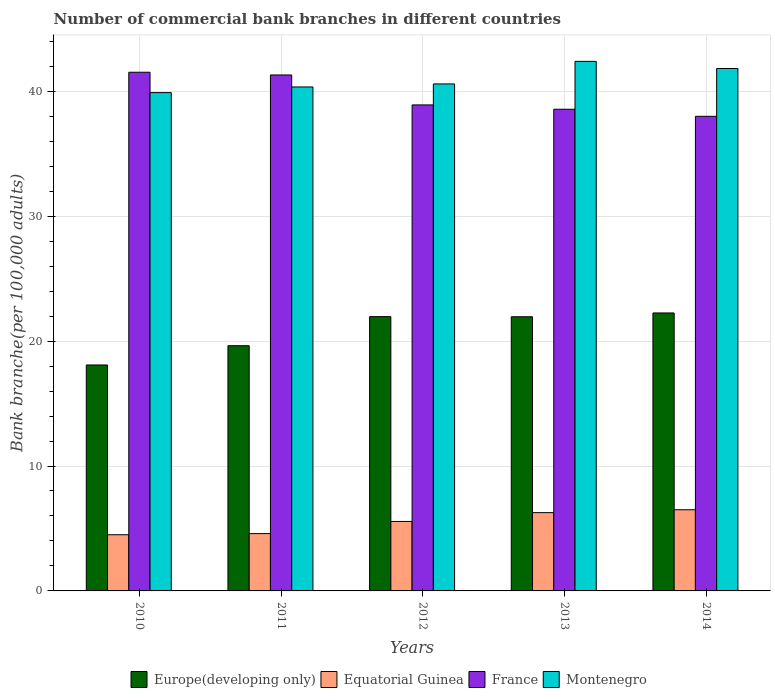Are the number of bars per tick equal to the number of legend labels?
Give a very brief answer. Yes. How many bars are there on the 4th tick from the right?
Provide a succinct answer. 4. What is the number of commercial bank branches in France in 2012?
Ensure brevity in your answer.  38.91. Across all years, what is the maximum number of commercial bank branches in Europe(developing only)?
Your response must be concise. 22.25. Across all years, what is the minimum number of commercial bank branches in Europe(developing only)?
Provide a succinct answer. 18.09. In which year was the number of commercial bank branches in France maximum?
Offer a very short reply. 2010. What is the total number of commercial bank branches in France in the graph?
Your answer should be compact. 198.3. What is the difference between the number of commercial bank branches in Equatorial Guinea in 2013 and that in 2014?
Make the answer very short. -0.23. What is the difference between the number of commercial bank branches in Europe(developing only) in 2011 and the number of commercial bank branches in France in 2014?
Ensure brevity in your answer.  -18.37. What is the average number of commercial bank branches in Europe(developing only) per year?
Give a very brief answer. 20.78. In the year 2012, what is the difference between the number of commercial bank branches in Europe(developing only) and number of commercial bank branches in Montenegro?
Give a very brief answer. -18.63. What is the ratio of the number of commercial bank branches in Europe(developing only) in 2011 to that in 2014?
Provide a succinct answer. 0.88. Is the difference between the number of commercial bank branches in Europe(developing only) in 2010 and 2013 greater than the difference between the number of commercial bank branches in Montenegro in 2010 and 2013?
Make the answer very short. No. What is the difference between the highest and the second highest number of commercial bank branches in France?
Keep it short and to the point. 0.22. What is the difference between the highest and the lowest number of commercial bank branches in Montenegro?
Keep it short and to the point. 2.5. In how many years, is the number of commercial bank branches in Europe(developing only) greater than the average number of commercial bank branches in Europe(developing only) taken over all years?
Offer a very short reply. 3. Is the sum of the number of commercial bank branches in Europe(developing only) in 2010 and 2012 greater than the maximum number of commercial bank branches in Montenegro across all years?
Keep it short and to the point. No. What does the 4th bar from the left in 2013 represents?
Provide a short and direct response. Montenegro. What does the 3rd bar from the right in 2014 represents?
Provide a succinct answer. Equatorial Guinea. Is it the case that in every year, the sum of the number of commercial bank branches in France and number of commercial bank branches in Equatorial Guinea is greater than the number of commercial bank branches in Montenegro?
Keep it short and to the point. Yes. How many bars are there?
Keep it short and to the point. 20. What is the difference between two consecutive major ticks on the Y-axis?
Your answer should be compact. 10. Are the values on the major ticks of Y-axis written in scientific E-notation?
Provide a short and direct response. No. Where does the legend appear in the graph?
Your answer should be very brief. Bottom center. How many legend labels are there?
Offer a terse response. 4. How are the legend labels stacked?
Ensure brevity in your answer.  Horizontal. What is the title of the graph?
Your response must be concise. Number of commercial bank branches in different countries. Does "Albania" appear as one of the legend labels in the graph?
Give a very brief answer. No. What is the label or title of the X-axis?
Give a very brief answer. Years. What is the label or title of the Y-axis?
Your response must be concise. Bank branche(per 100,0 adults). What is the Bank branche(per 100,000 adults) in Europe(developing only) in 2010?
Ensure brevity in your answer.  18.09. What is the Bank branche(per 100,000 adults) of Equatorial Guinea in 2010?
Keep it short and to the point. 4.5. What is the Bank branche(per 100,000 adults) of France in 2010?
Provide a short and direct response. 41.52. What is the Bank branche(per 100,000 adults) in Montenegro in 2010?
Offer a very short reply. 39.89. What is the Bank branche(per 100,000 adults) of Europe(developing only) in 2011?
Keep it short and to the point. 19.63. What is the Bank branche(per 100,000 adults) of Equatorial Guinea in 2011?
Keep it short and to the point. 4.59. What is the Bank branche(per 100,000 adults) in France in 2011?
Provide a short and direct response. 41.31. What is the Bank branche(per 100,000 adults) in Montenegro in 2011?
Your answer should be very brief. 40.35. What is the Bank branche(per 100,000 adults) of Europe(developing only) in 2012?
Offer a terse response. 21.96. What is the Bank branche(per 100,000 adults) of Equatorial Guinea in 2012?
Ensure brevity in your answer.  5.56. What is the Bank branche(per 100,000 adults) of France in 2012?
Your answer should be very brief. 38.91. What is the Bank branche(per 100,000 adults) of Montenegro in 2012?
Your answer should be compact. 40.59. What is the Bank branche(per 100,000 adults) in Europe(developing only) in 2013?
Provide a succinct answer. 21.95. What is the Bank branche(per 100,000 adults) in Equatorial Guinea in 2013?
Offer a terse response. 6.27. What is the Bank branche(per 100,000 adults) in France in 2013?
Your answer should be compact. 38.56. What is the Bank branche(per 100,000 adults) in Montenegro in 2013?
Provide a short and direct response. 42.4. What is the Bank branche(per 100,000 adults) in Europe(developing only) in 2014?
Your answer should be compact. 22.25. What is the Bank branche(per 100,000 adults) in Equatorial Guinea in 2014?
Your answer should be very brief. 6.5. What is the Bank branche(per 100,000 adults) of France in 2014?
Offer a very short reply. 38. What is the Bank branche(per 100,000 adults) of Montenegro in 2014?
Your answer should be compact. 41.82. Across all years, what is the maximum Bank branche(per 100,000 adults) in Europe(developing only)?
Give a very brief answer. 22.25. Across all years, what is the maximum Bank branche(per 100,000 adults) of Equatorial Guinea?
Your answer should be very brief. 6.5. Across all years, what is the maximum Bank branche(per 100,000 adults) of France?
Offer a terse response. 41.52. Across all years, what is the maximum Bank branche(per 100,000 adults) in Montenegro?
Give a very brief answer. 42.4. Across all years, what is the minimum Bank branche(per 100,000 adults) of Europe(developing only)?
Keep it short and to the point. 18.09. Across all years, what is the minimum Bank branche(per 100,000 adults) of Equatorial Guinea?
Ensure brevity in your answer.  4.5. Across all years, what is the minimum Bank branche(per 100,000 adults) in France?
Ensure brevity in your answer.  38. Across all years, what is the minimum Bank branche(per 100,000 adults) of Montenegro?
Keep it short and to the point. 39.89. What is the total Bank branche(per 100,000 adults) in Europe(developing only) in the graph?
Your response must be concise. 103.88. What is the total Bank branche(per 100,000 adults) of Equatorial Guinea in the graph?
Give a very brief answer. 27.41. What is the total Bank branche(per 100,000 adults) of France in the graph?
Your answer should be very brief. 198.3. What is the total Bank branche(per 100,000 adults) of Montenegro in the graph?
Keep it short and to the point. 205.04. What is the difference between the Bank branche(per 100,000 adults) in Europe(developing only) in 2010 and that in 2011?
Your answer should be very brief. -1.54. What is the difference between the Bank branche(per 100,000 adults) of Equatorial Guinea in 2010 and that in 2011?
Give a very brief answer. -0.09. What is the difference between the Bank branche(per 100,000 adults) of France in 2010 and that in 2011?
Offer a very short reply. 0.22. What is the difference between the Bank branche(per 100,000 adults) of Montenegro in 2010 and that in 2011?
Provide a succinct answer. -0.46. What is the difference between the Bank branche(per 100,000 adults) of Europe(developing only) in 2010 and that in 2012?
Keep it short and to the point. -3.87. What is the difference between the Bank branche(per 100,000 adults) in Equatorial Guinea in 2010 and that in 2012?
Your response must be concise. -1.06. What is the difference between the Bank branche(per 100,000 adults) in France in 2010 and that in 2012?
Make the answer very short. 2.62. What is the difference between the Bank branche(per 100,000 adults) in Montenegro in 2010 and that in 2012?
Give a very brief answer. -0.7. What is the difference between the Bank branche(per 100,000 adults) in Europe(developing only) in 2010 and that in 2013?
Provide a short and direct response. -3.86. What is the difference between the Bank branche(per 100,000 adults) in Equatorial Guinea in 2010 and that in 2013?
Offer a terse response. -1.77. What is the difference between the Bank branche(per 100,000 adults) in France in 2010 and that in 2013?
Provide a succinct answer. 2.96. What is the difference between the Bank branche(per 100,000 adults) in Montenegro in 2010 and that in 2013?
Offer a terse response. -2.5. What is the difference between the Bank branche(per 100,000 adults) in Europe(developing only) in 2010 and that in 2014?
Your answer should be very brief. -4.16. What is the difference between the Bank branche(per 100,000 adults) of Equatorial Guinea in 2010 and that in 2014?
Your answer should be very brief. -2. What is the difference between the Bank branche(per 100,000 adults) of France in 2010 and that in 2014?
Your answer should be compact. 3.53. What is the difference between the Bank branche(per 100,000 adults) in Montenegro in 2010 and that in 2014?
Your response must be concise. -1.93. What is the difference between the Bank branche(per 100,000 adults) in Europe(developing only) in 2011 and that in 2012?
Provide a succinct answer. -2.33. What is the difference between the Bank branche(per 100,000 adults) of Equatorial Guinea in 2011 and that in 2012?
Keep it short and to the point. -0.97. What is the difference between the Bank branche(per 100,000 adults) in France in 2011 and that in 2012?
Your answer should be very brief. 2.4. What is the difference between the Bank branche(per 100,000 adults) of Montenegro in 2011 and that in 2012?
Offer a terse response. -0.24. What is the difference between the Bank branche(per 100,000 adults) in Europe(developing only) in 2011 and that in 2013?
Your answer should be very brief. -2.32. What is the difference between the Bank branche(per 100,000 adults) in Equatorial Guinea in 2011 and that in 2013?
Give a very brief answer. -1.68. What is the difference between the Bank branche(per 100,000 adults) in France in 2011 and that in 2013?
Your answer should be very brief. 2.74. What is the difference between the Bank branche(per 100,000 adults) in Montenegro in 2011 and that in 2013?
Your answer should be very brief. -2.05. What is the difference between the Bank branche(per 100,000 adults) of Europe(developing only) in 2011 and that in 2014?
Your answer should be compact. -2.62. What is the difference between the Bank branche(per 100,000 adults) of Equatorial Guinea in 2011 and that in 2014?
Provide a short and direct response. -1.91. What is the difference between the Bank branche(per 100,000 adults) in France in 2011 and that in 2014?
Offer a terse response. 3.31. What is the difference between the Bank branche(per 100,000 adults) in Montenegro in 2011 and that in 2014?
Your answer should be compact. -1.48. What is the difference between the Bank branche(per 100,000 adults) in Europe(developing only) in 2012 and that in 2013?
Ensure brevity in your answer.  0.01. What is the difference between the Bank branche(per 100,000 adults) of Equatorial Guinea in 2012 and that in 2013?
Ensure brevity in your answer.  -0.71. What is the difference between the Bank branche(per 100,000 adults) of France in 2012 and that in 2013?
Keep it short and to the point. 0.35. What is the difference between the Bank branche(per 100,000 adults) of Montenegro in 2012 and that in 2013?
Ensure brevity in your answer.  -1.81. What is the difference between the Bank branche(per 100,000 adults) in Europe(developing only) in 2012 and that in 2014?
Your answer should be compact. -0.29. What is the difference between the Bank branche(per 100,000 adults) of Equatorial Guinea in 2012 and that in 2014?
Provide a succinct answer. -0.94. What is the difference between the Bank branche(per 100,000 adults) of France in 2012 and that in 2014?
Provide a short and direct response. 0.91. What is the difference between the Bank branche(per 100,000 adults) of Montenegro in 2012 and that in 2014?
Make the answer very short. -1.23. What is the difference between the Bank branche(per 100,000 adults) in Europe(developing only) in 2013 and that in 2014?
Your response must be concise. -0.3. What is the difference between the Bank branche(per 100,000 adults) in Equatorial Guinea in 2013 and that in 2014?
Offer a terse response. -0.23. What is the difference between the Bank branche(per 100,000 adults) of France in 2013 and that in 2014?
Offer a terse response. 0.57. What is the difference between the Bank branche(per 100,000 adults) of Montenegro in 2013 and that in 2014?
Keep it short and to the point. 0.57. What is the difference between the Bank branche(per 100,000 adults) of Europe(developing only) in 2010 and the Bank branche(per 100,000 adults) of Equatorial Guinea in 2011?
Provide a short and direct response. 13.5. What is the difference between the Bank branche(per 100,000 adults) in Europe(developing only) in 2010 and the Bank branche(per 100,000 adults) in France in 2011?
Your answer should be very brief. -23.22. What is the difference between the Bank branche(per 100,000 adults) of Europe(developing only) in 2010 and the Bank branche(per 100,000 adults) of Montenegro in 2011?
Provide a short and direct response. -22.26. What is the difference between the Bank branche(per 100,000 adults) in Equatorial Guinea in 2010 and the Bank branche(per 100,000 adults) in France in 2011?
Offer a very short reply. -36.81. What is the difference between the Bank branche(per 100,000 adults) in Equatorial Guinea in 2010 and the Bank branche(per 100,000 adults) in Montenegro in 2011?
Your response must be concise. -35.85. What is the difference between the Bank branche(per 100,000 adults) of France in 2010 and the Bank branche(per 100,000 adults) of Montenegro in 2011?
Your answer should be compact. 1.18. What is the difference between the Bank branche(per 100,000 adults) of Europe(developing only) in 2010 and the Bank branche(per 100,000 adults) of Equatorial Guinea in 2012?
Your answer should be very brief. 12.53. What is the difference between the Bank branche(per 100,000 adults) in Europe(developing only) in 2010 and the Bank branche(per 100,000 adults) in France in 2012?
Provide a short and direct response. -20.82. What is the difference between the Bank branche(per 100,000 adults) in Europe(developing only) in 2010 and the Bank branche(per 100,000 adults) in Montenegro in 2012?
Ensure brevity in your answer.  -22.5. What is the difference between the Bank branche(per 100,000 adults) in Equatorial Guinea in 2010 and the Bank branche(per 100,000 adults) in France in 2012?
Your answer should be very brief. -34.41. What is the difference between the Bank branche(per 100,000 adults) of Equatorial Guinea in 2010 and the Bank branche(per 100,000 adults) of Montenegro in 2012?
Provide a short and direct response. -36.09. What is the difference between the Bank branche(per 100,000 adults) in France in 2010 and the Bank branche(per 100,000 adults) in Montenegro in 2012?
Provide a short and direct response. 0.94. What is the difference between the Bank branche(per 100,000 adults) in Europe(developing only) in 2010 and the Bank branche(per 100,000 adults) in Equatorial Guinea in 2013?
Make the answer very short. 11.82. What is the difference between the Bank branche(per 100,000 adults) in Europe(developing only) in 2010 and the Bank branche(per 100,000 adults) in France in 2013?
Your response must be concise. -20.47. What is the difference between the Bank branche(per 100,000 adults) of Europe(developing only) in 2010 and the Bank branche(per 100,000 adults) of Montenegro in 2013?
Ensure brevity in your answer.  -24.31. What is the difference between the Bank branche(per 100,000 adults) in Equatorial Guinea in 2010 and the Bank branche(per 100,000 adults) in France in 2013?
Give a very brief answer. -34.06. What is the difference between the Bank branche(per 100,000 adults) in Equatorial Guinea in 2010 and the Bank branche(per 100,000 adults) in Montenegro in 2013?
Offer a very short reply. -37.9. What is the difference between the Bank branche(per 100,000 adults) in France in 2010 and the Bank branche(per 100,000 adults) in Montenegro in 2013?
Your response must be concise. -0.87. What is the difference between the Bank branche(per 100,000 adults) of Europe(developing only) in 2010 and the Bank branche(per 100,000 adults) of Equatorial Guinea in 2014?
Offer a terse response. 11.59. What is the difference between the Bank branche(per 100,000 adults) of Europe(developing only) in 2010 and the Bank branche(per 100,000 adults) of France in 2014?
Provide a short and direct response. -19.91. What is the difference between the Bank branche(per 100,000 adults) of Europe(developing only) in 2010 and the Bank branche(per 100,000 adults) of Montenegro in 2014?
Provide a succinct answer. -23.73. What is the difference between the Bank branche(per 100,000 adults) of Equatorial Guinea in 2010 and the Bank branche(per 100,000 adults) of France in 2014?
Your answer should be very brief. -33.5. What is the difference between the Bank branche(per 100,000 adults) of Equatorial Guinea in 2010 and the Bank branche(per 100,000 adults) of Montenegro in 2014?
Offer a very short reply. -37.32. What is the difference between the Bank branche(per 100,000 adults) of France in 2010 and the Bank branche(per 100,000 adults) of Montenegro in 2014?
Provide a short and direct response. -0.3. What is the difference between the Bank branche(per 100,000 adults) of Europe(developing only) in 2011 and the Bank branche(per 100,000 adults) of Equatorial Guinea in 2012?
Provide a succinct answer. 14.07. What is the difference between the Bank branche(per 100,000 adults) in Europe(developing only) in 2011 and the Bank branche(per 100,000 adults) in France in 2012?
Ensure brevity in your answer.  -19.28. What is the difference between the Bank branche(per 100,000 adults) in Europe(developing only) in 2011 and the Bank branche(per 100,000 adults) in Montenegro in 2012?
Ensure brevity in your answer.  -20.96. What is the difference between the Bank branche(per 100,000 adults) of Equatorial Guinea in 2011 and the Bank branche(per 100,000 adults) of France in 2012?
Offer a very short reply. -34.32. What is the difference between the Bank branche(per 100,000 adults) of Equatorial Guinea in 2011 and the Bank branche(per 100,000 adults) of Montenegro in 2012?
Your response must be concise. -36. What is the difference between the Bank branche(per 100,000 adults) in France in 2011 and the Bank branche(per 100,000 adults) in Montenegro in 2012?
Offer a terse response. 0.72. What is the difference between the Bank branche(per 100,000 adults) in Europe(developing only) in 2011 and the Bank branche(per 100,000 adults) in Equatorial Guinea in 2013?
Provide a short and direct response. 13.36. What is the difference between the Bank branche(per 100,000 adults) in Europe(developing only) in 2011 and the Bank branche(per 100,000 adults) in France in 2013?
Give a very brief answer. -18.93. What is the difference between the Bank branche(per 100,000 adults) in Europe(developing only) in 2011 and the Bank branche(per 100,000 adults) in Montenegro in 2013?
Offer a terse response. -22.77. What is the difference between the Bank branche(per 100,000 adults) of Equatorial Guinea in 2011 and the Bank branche(per 100,000 adults) of France in 2013?
Provide a succinct answer. -33.97. What is the difference between the Bank branche(per 100,000 adults) of Equatorial Guinea in 2011 and the Bank branche(per 100,000 adults) of Montenegro in 2013?
Keep it short and to the point. -37.81. What is the difference between the Bank branche(per 100,000 adults) of France in 2011 and the Bank branche(per 100,000 adults) of Montenegro in 2013?
Your answer should be compact. -1.09. What is the difference between the Bank branche(per 100,000 adults) of Europe(developing only) in 2011 and the Bank branche(per 100,000 adults) of Equatorial Guinea in 2014?
Your answer should be compact. 13.13. What is the difference between the Bank branche(per 100,000 adults) in Europe(developing only) in 2011 and the Bank branche(per 100,000 adults) in France in 2014?
Make the answer very short. -18.37. What is the difference between the Bank branche(per 100,000 adults) in Europe(developing only) in 2011 and the Bank branche(per 100,000 adults) in Montenegro in 2014?
Your response must be concise. -22.19. What is the difference between the Bank branche(per 100,000 adults) in Equatorial Guinea in 2011 and the Bank branche(per 100,000 adults) in France in 2014?
Provide a succinct answer. -33.41. What is the difference between the Bank branche(per 100,000 adults) in Equatorial Guinea in 2011 and the Bank branche(per 100,000 adults) in Montenegro in 2014?
Your response must be concise. -37.23. What is the difference between the Bank branche(per 100,000 adults) in France in 2011 and the Bank branche(per 100,000 adults) in Montenegro in 2014?
Your response must be concise. -0.52. What is the difference between the Bank branche(per 100,000 adults) in Europe(developing only) in 2012 and the Bank branche(per 100,000 adults) in Equatorial Guinea in 2013?
Your answer should be compact. 15.69. What is the difference between the Bank branche(per 100,000 adults) of Europe(developing only) in 2012 and the Bank branche(per 100,000 adults) of France in 2013?
Make the answer very short. -16.6. What is the difference between the Bank branche(per 100,000 adults) in Europe(developing only) in 2012 and the Bank branche(per 100,000 adults) in Montenegro in 2013?
Keep it short and to the point. -20.44. What is the difference between the Bank branche(per 100,000 adults) in Equatorial Guinea in 2012 and the Bank branche(per 100,000 adults) in France in 2013?
Offer a terse response. -33. What is the difference between the Bank branche(per 100,000 adults) of Equatorial Guinea in 2012 and the Bank branche(per 100,000 adults) of Montenegro in 2013?
Give a very brief answer. -36.83. What is the difference between the Bank branche(per 100,000 adults) of France in 2012 and the Bank branche(per 100,000 adults) of Montenegro in 2013?
Provide a short and direct response. -3.49. What is the difference between the Bank branche(per 100,000 adults) of Europe(developing only) in 2012 and the Bank branche(per 100,000 adults) of Equatorial Guinea in 2014?
Your response must be concise. 15.46. What is the difference between the Bank branche(per 100,000 adults) in Europe(developing only) in 2012 and the Bank branche(per 100,000 adults) in France in 2014?
Your response must be concise. -16.04. What is the difference between the Bank branche(per 100,000 adults) in Europe(developing only) in 2012 and the Bank branche(per 100,000 adults) in Montenegro in 2014?
Give a very brief answer. -19.86. What is the difference between the Bank branche(per 100,000 adults) of Equatorial Guinea in 2012 and the Bank branche(per 100,000 adults) of France in 2014?
Make the answer very short. -32.43. What is the difference between the Bank branche(per 100,000 adults) in Equatorial Guinea in 2012 and the Bank branche(per 100,000 adults) in Montenegro in 2014?
Offer a very short reply. -36.26. What is the difference between the Bank branche(per 100,000 adults) in France in 2012 and the Bank branche(per 100,000 adults) in Montenegro in 2014?
Offer a terse response. -2.91. What is the difference between the Bank branche(per 100,000 adults) in Europe(developing only) in 2013 and the Bank branche(per 100,000 adults) in Equatorial Guinea in 2014?
Your answer should be compact. 15.45. What is the difference between the Bank branche(per 100,000 adults) of Europe(developing only) in 2013 and the Bank branche(per 100,000 adults) of France in 2014?
Ensure brevity in your answer.  -16.05. What is the difference between the Bank branche(per 100,000 adults) of Europe(developing only) in 2013 and the Bank branche(per 100,000 adults) of Montenegro in 2014?
Your answer should be compact. -19.87. What is the difference between the Bank branche(per 100,000 adults) of Equatorial Guinea in 2013 and the Bank branche(per 100,000 adults) of France in 2014?
Keep it short and to the point. -31.73. What is the difference between the Bank branche(per 100,000 adults) of Equatorial Guinea in 2013 and the Bank branche(per 100,000 adults) of Montenegro in 2014?
Offer a very short reply. -35.55. What is the difference between the Bank branche(per 100,000 adults) in France in 2013 and the Bank branche(per 100,000 adults) in Montenegro in 2014?
Offer a very short reply. -3.26. What is the average Bank branche(per 100,000 adults) in Europe(developing only) per year?
Ensure brevity in your answer.  20.78. What is the average Bank branche(per 100,000 adults) in Equatorial Guinea per year?
Provide a succinct answer. 5.48. What is the average Bank branche(per 100,000 adults) in France per year?
Your answer should be very brief. 39.66. What is the average Bank branche(per 100,000 adults) of Montenegro per year?
Offer a terse response. 41.01. In the year 2010, what is the difference between the Bank branche(per 100,000 adults) in Europe(developing only) and Bank branche(per 100,000 adults) in Equatorial Guinea?
Keep it short and to the point. 13.59. In the year 2010, what is the difference between the Bank branche(per 100,000 adults) in Europe(developing only) and Bank branche(per 100,000 adults) in France?
Provide a short and direct response. -23.44. In the year 2010, what is the difference between the Bank branche(per 100,000 adults) in Europe(developing only) and Bank branche(per 100,000 adults) in Montenegro?
Offer a terse response. -21.8. In the year 2010, what is the difference between the Bank branche(per 100,000 adults) of Equatorial Guinea and Bank branche(per 100,000 adults) of France?
Offer a terse response. -37.03. In the year 2010, what is the difference between the Bank branche(per 100,000 adults) of Equatorial Guinea and Bank branche(per 100,000 adults) of Montenegro?
Give a very brief answer. -35.39. In the year 2010, what is the difference between the Bank branche(per 100,000 adults) of France and Bank branche(per 100,000 adults) of Montenegro?
Make the answer very short. 1.63. In the year 2011, what is the difference between the Bank branche(per 100,000 adults) in Europe(developing only) and Bank branche(per 100,000 adults) in Equatorial Guinea?
Your answer should be very brief. 15.04. In the year 2011, what is the difference between the Bank branche(per 100,000 adults) of Europe(developing only) and Bank branche(per 100,000 adults) of France?
Give a very brief answer. -21.68. In the year 2011, what is the difference between the Bank branche(per 100,000 adults) of Europe(developing only) and Bank branche(per 100,000 adults) of Montenegro?
Keep it short and to the point. -20.72. In the year 2011, what is the difference between the Bank branche(per 100,000 adults) in Equatorial Guinea and Bank branche(per 100,000 adults) in France?
Your response must be concise. -36.72. In the year 2011, what is the difference between the Bank branche(per 100,000 adults) in Equatorial Guinea and Bank branche(per 100,000 adults) in Montenegro?
Your answer should be very brief. -35.76. In the year 2011, what is the difference between the Bank branche(per 100,000 adults) of France and Bank branche(per 100,000 adults) of Montenegro?
Your response must be concise. 0.96. In the year 2012, what is the difference between the Bank branche(per 100,000 adults) of Europe(developing only) and Bank branche(per 100,000 adults) of Equatorial Guinea?
Your answer should be very brief. 16.4. In the year 2012, what is the difference between the Bank branche(per 100,000 adults) in Europe(developing only) and Bank branche(per 100,000 adults) in France?
Your answer should be very brief. -16.95. In the year 2012, what is the difference between the Bank branche(per 100,000 adults) in Europe(developing only) and Bank branche(per 100,000 adults) in Montenegro?
Keep it short and to the point. -18.63. In the year 2012, what is the difference between the Bank branche(per 100,000 adults) of Equatorial Guinea and Bank branche(per 100,000 adults) of France?
Your response must be concise. -33.35. In the year 2012, what is the difference between the Bank branche(per 100,000 adults) in Equatorial Guinea and Bank branche(per 100,000 adults) in Montenegro?
Give a very brief answer. -35.03. In the year 2012, what is the difference between the Bank branche(per 100,000 adults) of France and Bank branche(per 100,000 adults) of Montenegro?
Your answer should be very brief. -1.68. In the year 2013, what is the difference between the Bank branche(per 100,000 adults) in Europe(developing only) and Bank branche(per 100,000 adults) in Equatorial Guinea?
Give a very brief answer. 15.68. In the year 2013, what is the difference between the Bank branche(per 100,000 adults) of Europe(developing only) and Bank branche(per 100,000 adults) of France?
Keep it short and to the point. -16.61. In the year 2013, what is the difference between the Bank branche(per 100,000 adults) in Europe(developing only) and Bank branche(per 100,000 adults) in Montenegro?
Keep it short and to the point. -20.45. In the year 2013, what is the difference between the Bank branche(per 100,000 adults) in Equatorial Guinea and Bank branche(per 100,000 adults) in France?
Give a very brief answer. -32.29. In the year 2013, what is the difference between the Bank branche(per 100,000 adults) of Equatorial Guinea and Bank branche(per 100,000 adults) of Montenegro?
Your answer should be very brief. -36.13. In the year 2013, what is the difference between the Bank branche(per 100,000 adults) of France and Bank branche(per 100,000 adults) of Montenegro?
Give a very brief answer. -3.83. In the year 2014, what is the difference between the Bank branche(per 100,000 adults) in Europe(developing only) and Bank branche(per 100,000 adults) in Equatorial Guinea?
Make the answer very short. 15.75. In the year 2014, what is the difference between the Bank branche(per 100,000 adults) in Europe(developing only) and Bank branche(per 100,000 adults) in France?
Ensure brevity in your answer.  -15.74. In the year 2014, what is the difference between the Bank branche(per 100,000 adults) of Europe(developing only) and Bank branche(per 100,000 adults) of Montenegro?
Give a very brief answer. -19.57. In the year 2014, what is the difference between the Bank branche(per 100,000 adults) of Equatorial Guinea and Bank branche(per 100,000 adults) of France?
Provide a succinct answer. -31.5. In the year 2014, what is the difference between the Bank branche(per 100,000 adults) of Equatorial Guinea and Bank branche(per 100,000 adults) of Montenegro?
Keep it short and to the point. -35.32. In the year 2014, what is the difference between the Bank branche(per 100,000 adults) in France and Bank branche(per 100,000 adults) in Montenegro?
Provide a succinct answer. -3.83. What is the ratio of the Bank branche(per 100,000 adults) of Europe(developing only) in 2010 to that in 2011?
Your response must be concise. 0.92. What is the ratio of the Bank branche(per 100,000 adults) of Equatorial Guinea in 2010 to that in 2011?
Your answer should be compact. 0.98. What is the ratio of the Bank branche(per 100,000 adults) in France in 2010 to that in 2011?
Provide a short and direct response. 1.01. What is the ratio of the Bank branche(per 100,000 adults) of Montenegro in 2010 to that in 2011?
Give a very brief answer. 0.99. What is the ratio of the Bank branche(per 100,000 adults) of Europe(developing only) in 2010 to that in 2012?
Provide a short and direct response. 0.82. What is the ratio of the Bank branche(per 100,000 adults) in Equatorial Guinea in 2010 to that in 2012?
Give a very brief answer. 0.81. What is the ratio of the Bank branche(per 100,000 adults) of France in 2010 to that in 2012?
Provide a succinct answer. 1.07. What is the ratio of the Bank branche(per 100,000 adults) in Montenegro in 2010 to that in 2012?
Your answer should be compact. 0.98. What is the ratio of the Bank branche(per 100,000 adults) of Europe(developing only) in 2010 to that in 2013?
Give a very brief answer. 0.82. What is the ratio of the Bank branche(per 100,000 adults) of Equatorial Guinea in 2010 to that in 2013?
Offer a very short reply. 0.72. What is the ratio of the Bank branche(per 100,000 adults) of France in 2010 to that in 2013?
Your response must be concise. 1.08. What is the ratio of the Bank branche(per 100,000 adults) of Montenegro in 2010 to that in 2013?
Ensure brevity in your answer.  0.94. What is the ratio of the Bank branche(per 100,000 adults) of Europe(developing only) in 2010 to that in 2014?
Give a very brief answer. 0.81. What is the ratio of the Bank branche(per 100,000 adults) in Equatorial Guinea in 2010 to that in 2014?
Provide a succinct answer. 0.69. What is the ratio of the Bank branche(per 100,000 adults) in France in 2010 to that in 2014?
Ensure brevity in your answer.  1.09. What is the ratio of the Bank branche(per 100,000 adults) of Montenegro in 2010 to that in 2014?
Offer a terse response. 0.95. What is the ratio of the Bank branche(per 100,000 adults) in Europe(developing only) in 2011 to that in 2012?
Offer a terse response. 0.89. What is the ratio of the Bank branche(per 100,000 adults) of Equatorial Guinea in 2011 to that in 2012?
Offer a very short reply. 0.83. What is the ratio of the Bank branche(per 100,000 adults) of France in 2011 to that in 2012?
Keep it short and to the point. 1.06. What is the ratio of the Bank branche(per 100,000 adults) of Montenegro in 2011 to that in 2012?
Ensure brevity in your answer.  0.99. What is the ratio of the Bank branche(per 100,000 adults) of Europe(developing only) in 2011 to that in 2013?
Give a very brief answer. 0.89. What is the ratio of the Bank branche(per 100,000 adults) of Equatorial Guinea in 2011 to that in 2013?
Offer a terse response. 0.73. What is the ratio of the Bank branche(per 100,000 adults) of France in 2011 to that in 2013?
Ensure brevity in your answer.  1.07. What is the ratio of the Bank branche(per 100,000 adults) in Montenegro in 2011 to that in 2013?
Make the answer very short. 0.95. What is the ratio of the Bank branche(per 100,000 adults) in Europe(developing only) in 2011 to that in 2014?
Provide a short and direct response. 0.88. What is the ratio of the Bank branche(per 100,000 adults) in Equatorial Guinea in 2011 to that in 2014?
Make the answer very short. 0.71. What is the ratio of the Bank branche(per 100,000 adults) of France in 2011 to that in 2014?
Offer a very short reply. 1.09. What is the ratio of the Bank branche(per 100,000 adults) of Montenegro in 2011 to that in 2014?
Keep it short and to the point. 0.96. What is the ratio of the Bank branche(per 100,000 adults) in Equatorial Guinea in 2012 to that in 2013?
Provide a short and direct response. 0.89. What is the ratio of the Bank branche(per 100,000 adults) in Montenegro in 2012 to that in 2013?
Your answer should be very brief. 0.96. What is the ratio of the Bank branche(per 100,000 adults) of Europe(developing only) in 2012 to that in 2014?
Your answer should be compact. 0.99. What is the ratio of the Bank branche(per 100,000 adults) in Equatorial Guinea in 2012 to that in 2014?
Offer a very short reply. 0.86. What is the ratio of the Bank branche(per 100,000 adults) of France in 2012 to that in 2014?
Offer a terse response. 1.02. What is the ratio of the Bank branche(per 100,000 adults) of Montenegro in 2012 to that in 2014?
Make the answer very short. 0.97. What is the ratio of the Bank branche(per 100,000 adults) in Europe(developing only) in 2013 to that in 2014?
Give a very brief answer. 0.99. What is the ratio of the Bank branche(per 100,000 adults) of Equatorial Guinea in 2013 to that in 2014?
Offer a terse response. 0.96. What is the ratio of the Bank branche(per 100,000 adults) in France in 2013 to that in 2014?
Provide a short and direct response. 1.01. What is the ratio of the Bank branche(per 100,000 adults) in Montenegro in 2013 to that in 2014?
Ensure brevity in your answer.  1.01. What is the difference between the highest and the second highest Bank branche(per 100,000 adults) of Europe(developing only)?
Keep it short and to the point. 0.29. What is the difference between the highest and the second highest Bank branche(per 100,000 adults) in Equatorial Guinea?
Offer a terse response. 0.23. What is the difference between the highest and the second highest Bank branche(per 100,000 adults) of France?
Provide a succinct answer. 0.22. What is the difference between the highest and the second highest Bank branche(per 100,000 adults) in Montenegro?
Provide a short and direct response. 0.57. What is the difference between the highest and the lowest Bank branche(per 100,000 adults) in Europe(developing only)?
Give a very brief answer. 4.16. What is the difference between the highest and the lowest Bank branche(per 100,000 adults) of Equatorial Guinea?
Make the answer very short. 2. What is the difference between the highest and the lowest Bank branche(per 100,000 adults) of France?
Your answer should be compact. 3.53. What is the difference between the highest and the lowest Bank branche(per 100,000 adults) of Montenegro?
Your answer should be compact. 2.5. 